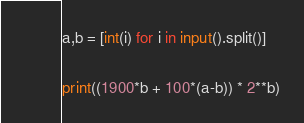Convert code to text. <code><loc_0><loc_0><loc_500><loc_500><_Python_>a,b = [int(i) for i in input().split()]

print((1900*b + 100*(a-b)) * 2**b)</code> 